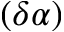Convert formula to latex. <formula><loc_0><loc_0><loc_500><loc_500>( \delta \alpha )</formula> 